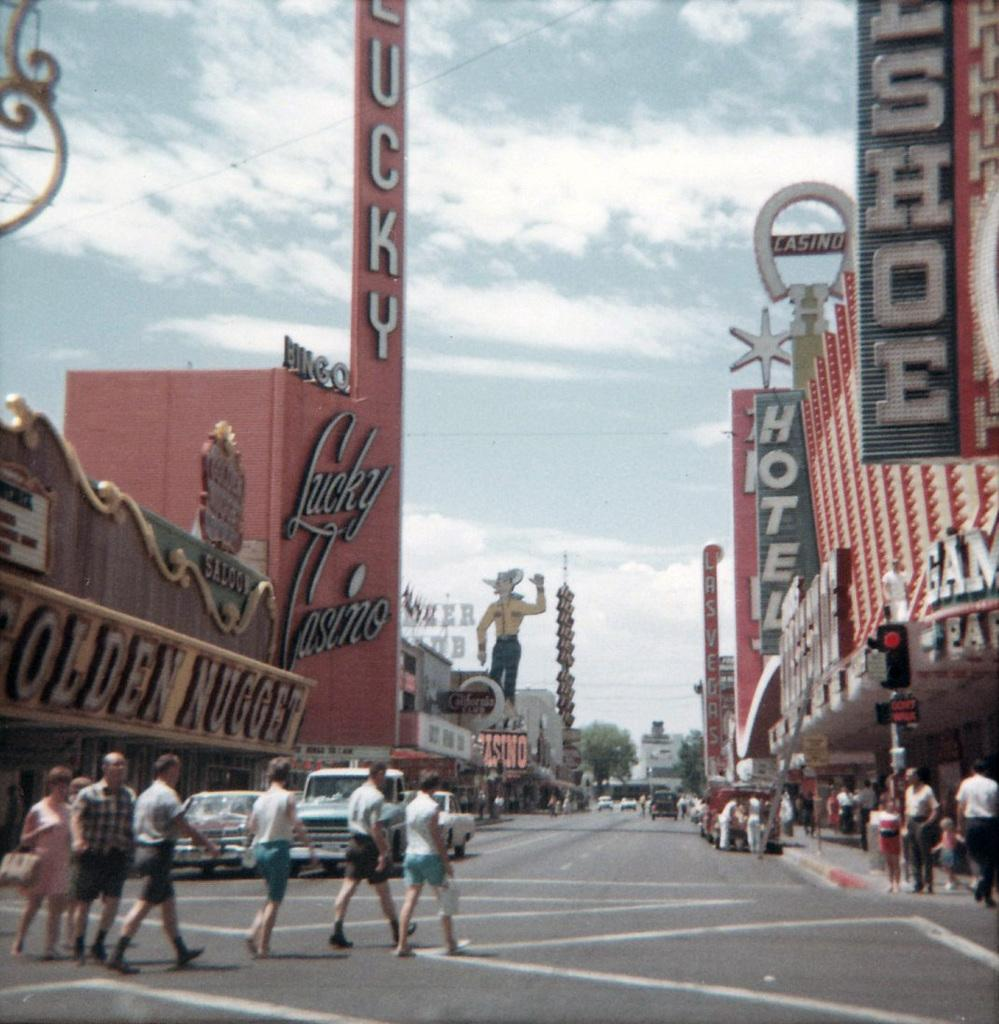What type of structures are present in the image? There are buildings in the image. Where can text be found in the image? Text is present in the left and right corners of the image. What other subjects can be seen in the image besides buildings? There are people and cars in the image. What part of the image shows a path for vehicles? The road is visible at the bottom of the image. What is visible above the buildings and other subjects in the image? The sky is visible at the top of the image. Can you see a goose flying in the sky in the image? There is no goose present in the image. What type of van is parked near the buildings in the image? There is no van present in the image. 